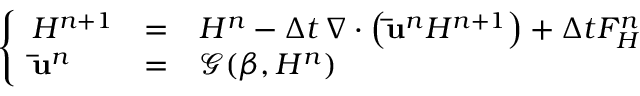<formula> <loc_0><loc_0><loc_500><loc_500>\left \{ \begin{array} { l l l } { H ^ { n + 1 } } & { = } & { H ^ { n } - \Delta t \, \nabla \cdot \left ( \bar { u } ^ { n } H ^ { n + 1 } \right ) + \Delta t F _ { H } ^ { n } } \\ { \bar { u } ^ { n } } & { = } & { \mathcal { G } ( \beta , H ^ { n } ) } \end{array}</formula> 